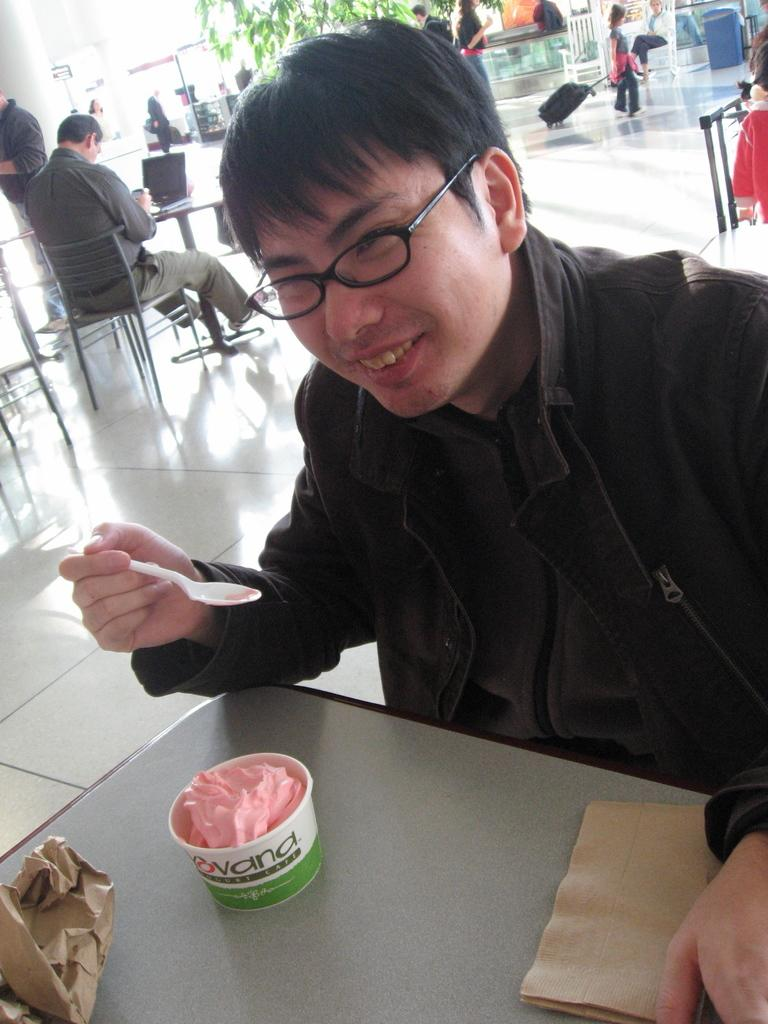What is the main subject of the image? There is a person in the image. What is the person doing in the image? The person is sitting on a chair and eating ice cream. What type of oatmeal is the person eating in the image? There is no oatmeal present in the image; the person is eating ice cream. Where did the person purchase the ice cream in the image? There is no information about where the person purchased the ice cream in the image. 